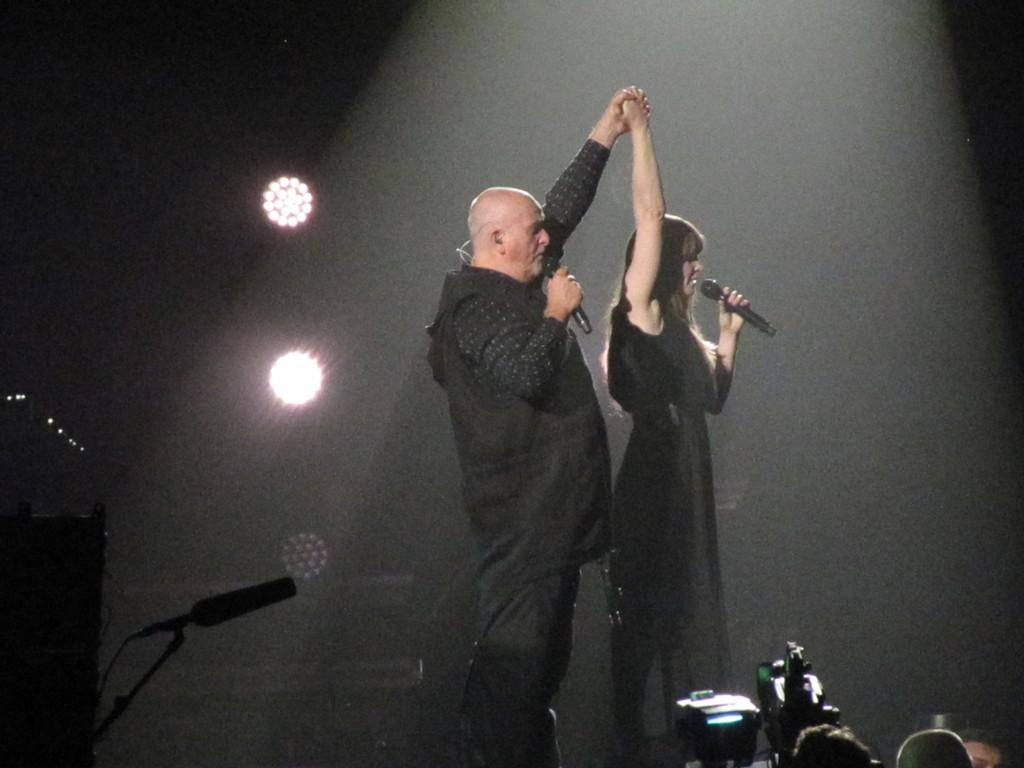How many people are in the image? There are two people in the image, a man and a woman. What are the man and woman doing in the image? The man and woman are standing and holding a microphone in their hands. What type of kite is the man flying in the image? There is no kite present in the image; the man and woman are holding a microphone. What is the temperature inside the oven in the image? There is no oven present in the image. 